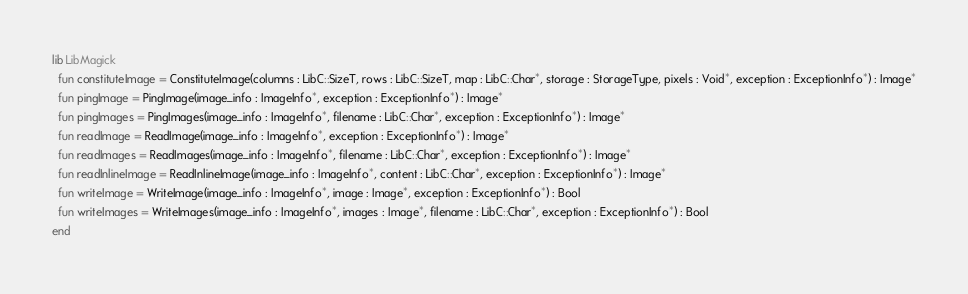Convert code to text. <code><loc_0><loc_0><loc_500><loc_500><_Crystal_>lib LibMagick
  fun constituteImage = ConstituteImage(columns : LibC::SizeT, rows : LibC::SizeT, map : LibC::Char*, storage : StorageType, pixels : Void*, exception : ExceptionInfo*) : Image*
  fun pingImage = PingImage(image_info : ImageInfo*, exception : ExceptionInfo*) : Image*
  fun pingImages = PingImages(image_info : ImageInfo*, filename : LibC::Char*, exception : ExceptionInfo*) : Image*
  fun readImage = ReadImage(image_info : ImageInfo*, exception : ExceptionInfo*) : Image*
  fun readImages = ReadImages(image_info : ImageInfo*, filename : LibC::Char*, exception : ExceptionInfo*) : Image*
  fun readInlineImage = ReadInlineImage(image_info : ImageInfo*, content : LibC::Char*, exception : ExceptionInfo*) : Image*
  fun writeImage = WriteImage(image_info : ImageInfo*, image : Image*, exception : ExceptionInfo*) : Bool
  fun writeImages = WriteImages(image_info : ImageInfo*, images : Image*, filename : LibC::Char*, exception : ExceptionInfo*) : Bool
end
</code> 